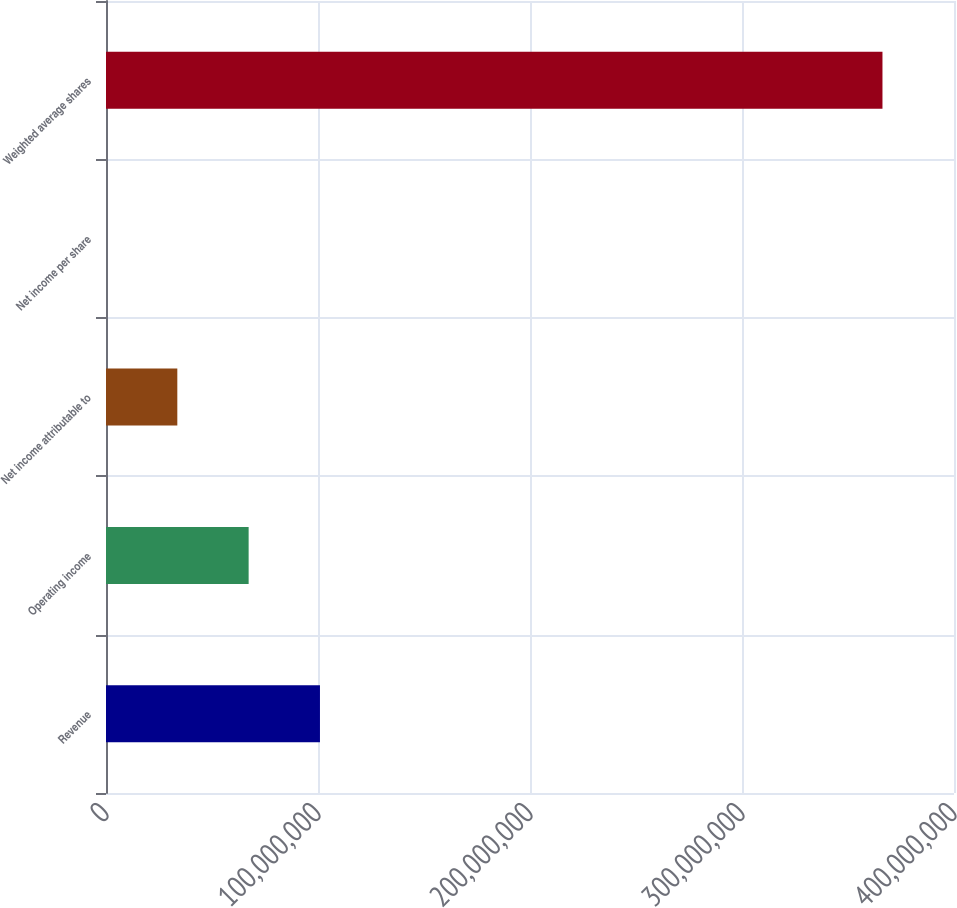Convert chart to OTSL. <chart><loc_0><loc_0><loc_500><loc_500><bar_chart><fcel>Revenue<fcel>Operating income<fcel>Net income attributable to<fcel>Net income per share<fcel>Weighted average shares<nl><fcel>1.00924e+08<fcel>6.7283e+07<fcel>3.36415e+07<fcel>1.75<fcel>3.66258e+08<nl></chart> 